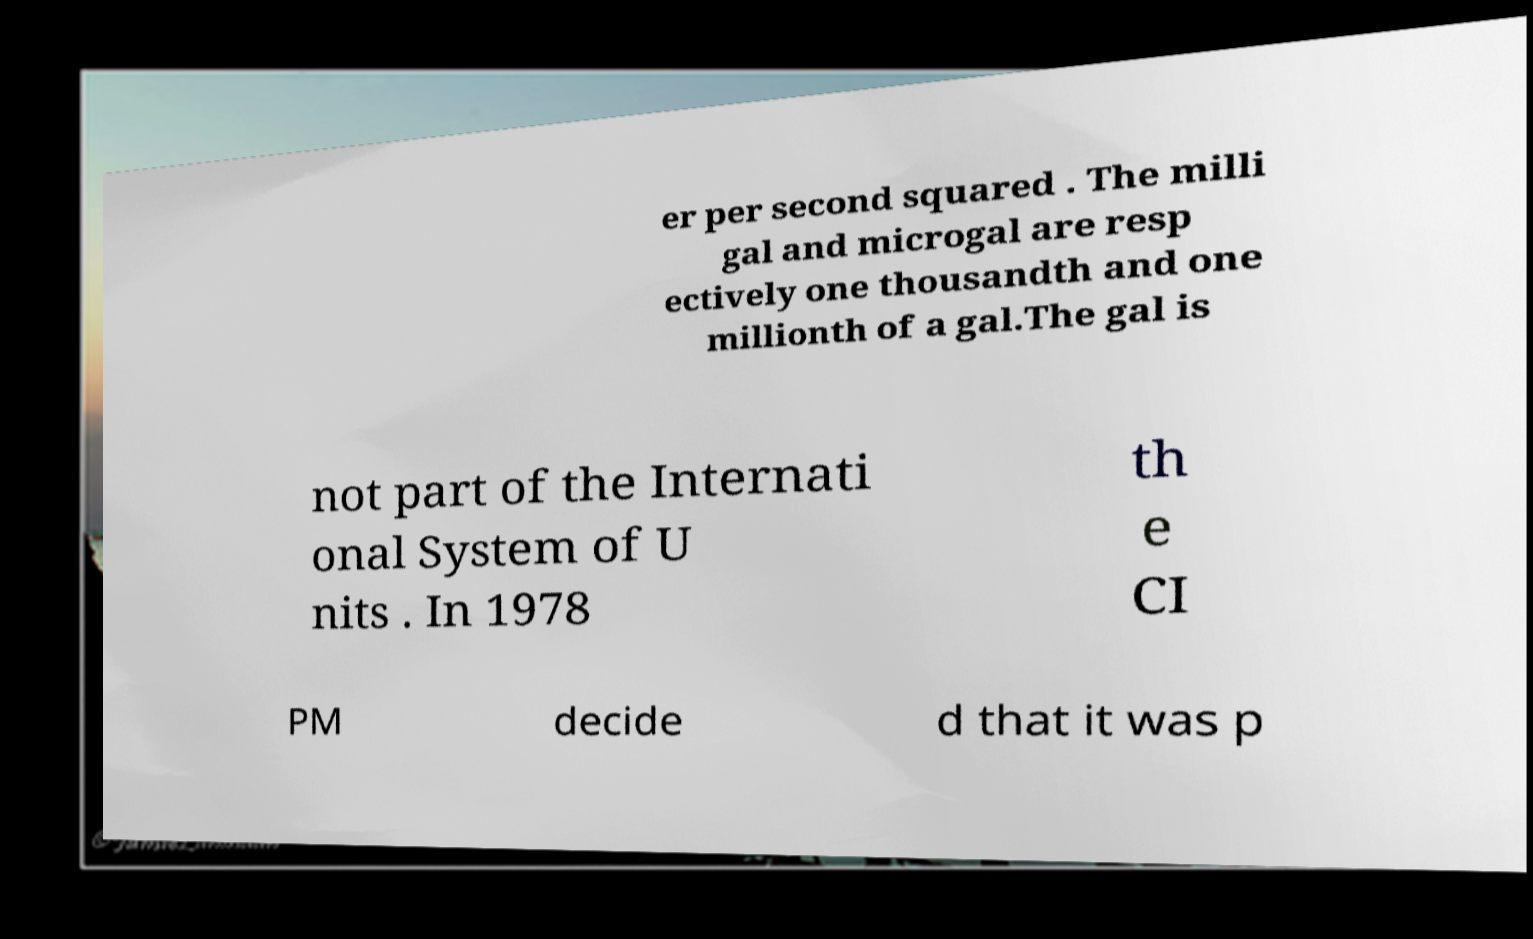For documentation purposes, I need the text within this image transcribed. Could you provide that? er per second squared . The milli gal and microgal are resp ectively one thousandth and one millionth of a gal.The gal is not part of the Internati onal System of U nits . In 1978 th e CI PM decide d that it was p 